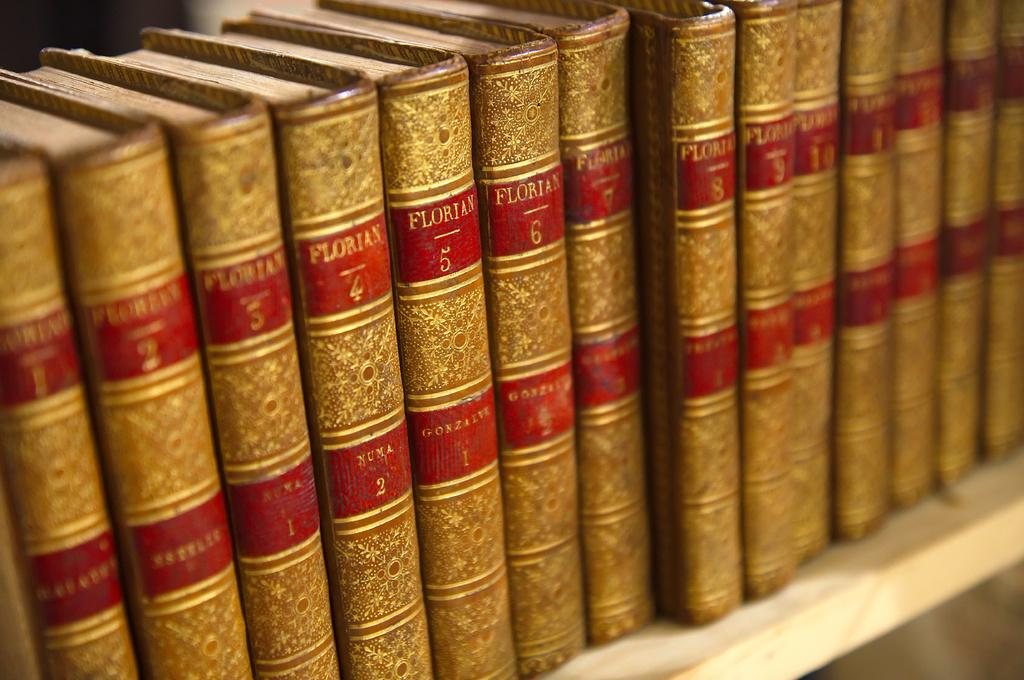<image>
Offer a succinct explanation of the picture presented. Books on a shelf including one that has the number 5 on the top. 